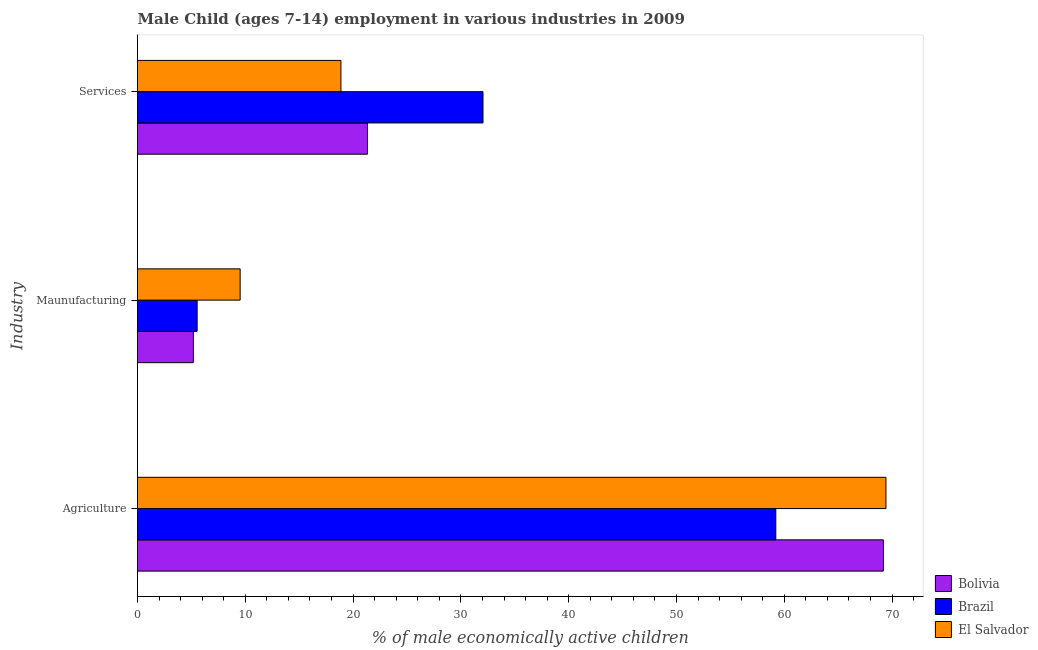How many different coloured bars are there?
Ensure brevity in your answer.  3. How many bars are there on the 1st tick from the bottom?
Offer a very short reply. 3. What is the label of the 1st group of bars from the top?
Ensure brevity in your answer.  Services. What is the percentage of economically active children in agriculture in Bolivia?
Keep it short and to the point. 69.19. Across all countries, what is the maximum percentage of economically active children in services?
Keep it short and to the point. 32.05. Across all countries, what is the minimum percentage of economically active children in agriculture?
Provide a short and direct response. 59.21. In which country was the percentage of economically active children in manufacturing maximum?
Ensure brevity in your answer.  El Salvador. What is the total percentage of economically active children in agriculture in the graph?
Give a very brief answer. 197.83. What is the difference between the percentage of economically active children in agriculture in Bolivia and that in Brazil?
Make the answer very short. 9.98. What is the difference between the percentage of economically active children in services in El Salvador and the percentage of economically active children in manufacturing in Brazil?
Ensure brevity in your answer.  13.34. What is the average percentage of economically active children in agriculture per country?
Your answer should be compact. 65.94. What is the difference between the percentage of economically active children in manufacturing and percentage of economically active children in agriculture in Bolivia?
Keep it short and to the point. -64.01. In how many countries, is the percentage of economically active children in services greater than 8 %?
Provide a short and direct response. 3. What is the ratio of the percentage of economically active children in manufacturing in Brazil to that in Bolivia?
Make the answer very short. 1.07. Is the difference between the percentage of economically active children in manufacturing in Bolivia and Brazil greater than the difference between the percentage of economically active children in services in Bolivia and Brazil?
Keep it short and to the point. Yes. What is the difference between the highest and the second highest percentage of economically active children in manufacturing?
Give a very brief answer. 3.99. What is the difference between the highest and the lowest percentage of economically active children in services?
Keep it short and to the point. 13.18. In how many countries, is the percentage of economically active children in services greater than the average percentage of economically active children in services taken over all countries?
Your answer should be very brief. 1. Is the sum of the percentage of economically active children in services in Brazil and Bolivia greater than the maximum percentage of economically active children in manufacturing across all countries?
Make the answer very short. Yes. Is it the case that in every country, the sum of the percentage of economically active children in agriculture and percentage of economically active children in manufacturing is greater than the percentage of economically active children in services?
Offer a terse response. Yes. How many bars are there?
Give a very brief answer. 9. Are all the bars in the graph horizontal?
Provide a short and direct response. Yes. How many countries are there in the graph?
Keep it short and to the point. 3. What is the title of the graph?
Provide a succinct answer. Male Child (ages 7-14) employment in various industries in 2009. What is the label or title of the X-axis?
Make the answer very short. % of male economically active children. What is the label or title of the Y-axis?
Keep it short and to the point. Industry. What is the % of male economically active children in Bolivia in Agriculture?
Provide a succinct answer. 69.19. What is the % of male economically active children in Brazil in Agriculture?
Your answer should be compact. 59.21. What is the % of male economically active children in El Salvador in Agriculture?
Offer a terse response. 69.43. What is the % of male economically active children of Bolivia in Maunufacturing?
Your response must be concise. 5.18. What is the % of male economically active children in Brazil in Maunufacturing?
Your response must be concise. 5.53. What is the % of male economically active children of El Salvador in Maunufacturing?
Your answer should be very brief. 9.52. What is the % of male economically active children of Bolivia in Services?
Your answer should be very brief. 21.33. What is the % of male economically active children of Brazil in Services?
Make the answer very short. 32.05. What is the % of male economically active children of El Salvador in Services?
Provide a short and direct response. 18.87. Across all Industry, what is the maximum % of male economically active children of Bolivia?
Offer a very short reply. 69.19. Across all Industry, what is the maximum % of male economically active children in Brazil?
Your response must be concise. 59.21. Across all Industry, what is the maximum % of male economically active children of El Salvador?
Your answer should be very brief. 69.43. Across all Industry, what is the minimum % of male economically active children in Bolivia?
Ensure brevity in your answer.  5.18. Across all Industry, what is the minimum % of male economically active children of Brazil?
Keep it short and to the point. 5.53. Across all Industry, what is the minimum % of male economically active children in El Salvador?
Offer a terse response. 9.52. What is the total % of male economically active children in Bolivia in the graph?
Make the answer very short. 95.7. What is the total % of male economically active children of Brazil in the graph?
Offer a terse response. 96.79. What is the total % of male economically active children in El Salvador in the graph?
Provide a short and direct response. 97.82. What is the difference between the % of male economically active children in Bolivia in Agriculture and that in Maunufacturing?
Give a very brief answer. 64.01. What is the difference between the % of male economically active children of Brazil in Agriculture and that in Maunufacturing?
Offer a terse response. 53.68. What is the difference between the % of male economically active children in El Salvador in Agriculture and that in Maunufacturing?
Ensure brevity in your answer.  59.91. What is the difference between the % of male economically active children in Bolivia in Agriculture and that in Services?
Ensure brevity in your answer.  47.86. What is the difference between the % of male economically active children of Brazil in Agriculture and that in Services?
Provide a succinct answer. 27.16. What is the difference between the % of male economically active children of El Salvador in Agriculture and that in Services?
Provide a short and direct response. 50.56. What is the difference between the % of male economically active children in Bolivia in Maunufacturing and that in Services?
Provide a short and direct response. -16.15. What is the difference between the % of male economically active children in Brazil in Maunufacturing and that in Services?
Provide a short and direct response. -26.52. What is the difference between the % of male economically active children in El Salvador in Maunufacturing and that in Services?
Give a very brief answer. -9.35. What is the difference between the % of male economically active children in Bolivia in Agriculture and the % of male economically active children in Brazil in Maunufacturing?
Keep it short and to the point. 63.66. What is the difference between the % of male economically active children of Bolivia in Agriculture and the % of male economically active children of El Salvador in Maunufacturing?
Provide a short and direct response. 59.67. What is the difference between the % of male economically active children in Brazil in Agriculture and the % of male economically active children in El Salvador in Maunufacturing?
Your response must be concise. 49.69. What is the difference between the % of male economically active children of Bolivia in Agriculture and the % of male economically active children of Brazil in Services?
Provide a succinct answer. 37.14. What is the difference between the % of male economically active children in Bolivia in Agriculture and the % of male economically active children in El Salvador in Services?
Ensure brevity in your answer.  50.32. What is the difference between the % of male economically active children of Brazil in Agriculture and the % of male economically active children of El Salvador in Services?
Ensure brevity in your answer.  40.34. What is the difference between the % of male economically active children in Bolivia in Maunufacturing and the % of male economically active children in Brazil in Services?
Your answer should be very brief. -26.87. What is the difference between the % of male economically active children in Bolivia in Maunufacturing and the % of male economically active children in El Salvador in Services?
Offer a terse response. -13.69. What is the difference between the % of male economically active children in Brazil in Maunufacturing and the % of male economically active children in El Salvador in Services?
Ensure brevity in your answer.  -13.34. What is the average % of male economically active children of Bolivia per Industry?
Provide a succinct answer. 31.9. What is the average % of male economically active children of Brazil per Industry?
Your answer should be compact. 32.26. What is the average % of male economically active children in El Salvador per Industry?
Give a very brief answer. 32.61. What is the difference between the % of male economically active children of Bolivia and % of male economically active children of Brazil in Agriculture?
Ensure brevity in your answer.  9.98. What is the difference between the % of male economically active children in Bolivia and % of male economically active children in El Salvador in Agriculture?
Provide a short and direct response. -0.24. What is the difference between the % of male economically active children in Brazil and % of male economically active children in El Salvador in Agriculture?
Your answer should be compact. -10.22. What is the difference between the % of male economically active children in Bolivia and % of male economically active children in Brazil in Maunufacturing?
Your answer should be very brief. -0.35. What is the difference between the % of male economically active children of Bolivia and % of male economically active children of El Salvador in Maunufacturing?
Ensure brevity in your answer.  -4.34. What is the difference between the % of male economically active children of Brazil and % of male economically active children of El Salvador in Maunufacturing?
Your response must be concise. -3.99. What is the difference between the % of male economically active children in Bolivia and % of male economically active children in Brazil in Services?
Keep it short and to the point. -10.72. What is the difference between the % of male economically active children in Bolivia and % of male economically active children in El Salvador in Services?
Ensure brevity in your answer.  2.46. What is the difference between the % of male economically active children of Brazil and % of male economically active children of El Salvador in Services?
Offer a terse response. 13.18. What is the ratio of the % of male economically active children of Bolivia in Agriculture to that in Maunufacturing?
Give a very brief answer. 13.36. What is the ratio of the % of male economically active children in Brazil in Agriculture to that in Maunufacturing?
Your answer should be very brief. 10.71. What is the ratio of the % of male economically active children of El Salvador in Agriculture to that in Maunufacturing?
Offer a terse response. 7.29. What is the ratio of the % of male economically active children of Bolivia in Agriculture to that in Services?
Your response must be concise. 3.24. What is the ratio of the % of male economically active children of Brazil in Agriculture to that in Services?
Ensure brevity in your answer.  1.85. What is the ratio of the % of male economically active children in El Salvador in Agriculture to that in Services?
Offer a very short reply. 3.68. What is the ratio of the % of male economically active children of Bolivia in Maunufacturing to that in Services?
Your answer should be compact. 0.24. What is the ratio of the % of male economically active children in Brazil in Maunufacturing to that in Services?
Ensure brevity in your answer.  0.17. What is the ratio of the % of male economically active children in El Salvador in Maunufacturing to that in Services?
Provide a short and direct response. 0.5. What is the difference between the highest and the second highest % of male economically active children in Bolivia?
Your answer should be very brief. 47.86. What is the difference between the highest and the second highest % of male economically active children in Brazil?
Provide a succinct answer. 27.16. What is the difference between the highest and the second highest % of male economically active children in El Salvador?
Your answer should be compact. 50.56. What is the difference between the highest and the lowest % of male economically active children of Bolivia?
Your answer should be compact. 64.01. What is the difference between the highest and the lowest % of male economically active children in Brazil?
Make the answer very short. 53.68. What is the difference between the highest and the lowest % of male economically active children of El Salvador?
Keep it short and to the point. 59.91. 